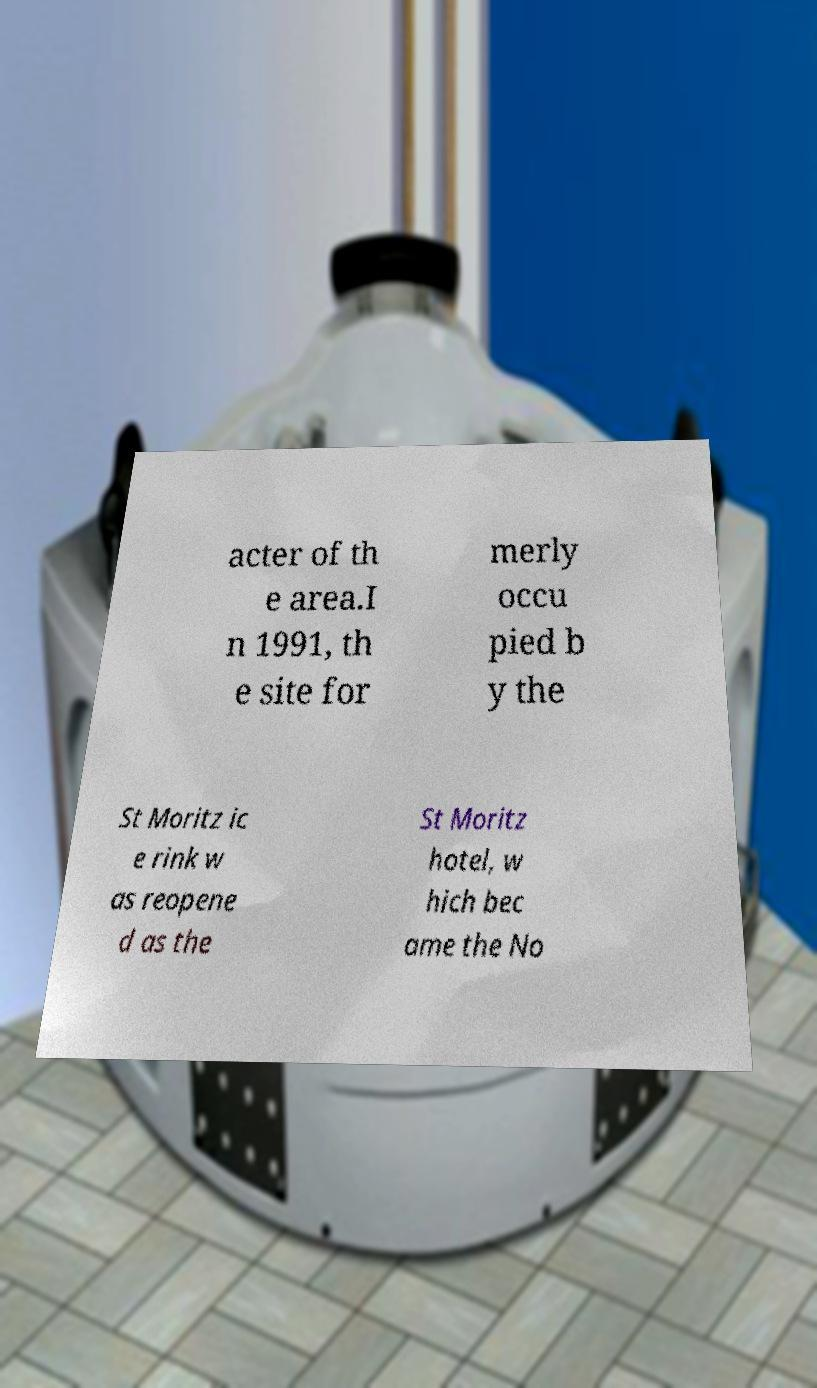For documentation purposes, I need the text within this image transcribed. Could you provide that? acter of th e area.I n 1991, th e site for merly occu pied b y the St Moritz ic e rink w as reopene d as the St Moritz hotel, w hich bec ame the No 